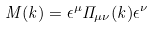Convert formula to latex. <formula><loc_0><loc_0><loc_500><loc_500>M ( k ) = \epsilon ^ { \mu } { \Pi } _ { \mu \nu } ( k ) \epsilon ^ { \nu }</formula> 